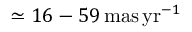Convert formula to latex. <formula><loc_0><loc_0><loc_500><loc_500>\simeq 1 6 - 5 9 \, m a s \, y r ^ { - 1 }</formula> 